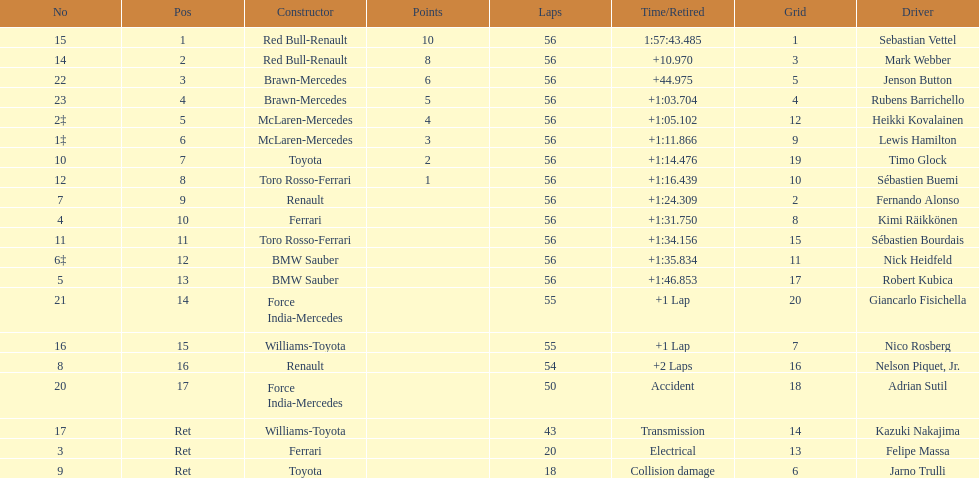What name is just previous to kazuki nakjima on the list? Adrian Sutil. Can you parse all the data within this table? {'header': ['No', 'Pos', 'Constructor', 'Points', 'Laps', 'Time/Retired', 'Grid', 'Driver'], 'rows': [['15', '1', 'Red Bull-Renault', '10', '56', '1:57:43.485', '1', 'Sebastian Vettel'], ['14', '2', 'Red Bull-Renault', '8', '56', '+10.970', '3', 'Mark Webber'], ['22', '3', 'Brawn-Mercedes', '6', '56', '+44.975', '5', 'Jenson Button'], ['23', '4', 'Brawn-Mercedes', '5', '56', '+1:03.704', '4', 'Rubens Barrichello'], ['2‡', '5', 'McLaren-Mercedes', '4', '56', '+1:05.102', '12', 'Heikki Kovalainen'], ['1‡', '6', 'McLaren-Mercedes', '3', '56', '+1:11.866', '9', 'Lewis Hamilton'], ['10', '7', 'Toyota', '2', '56', '+1:14.476', '19', 'Timo Glock'], ['12', '8', 'Toro Rosso-Ferrari', '1', '56', '+1:16.439', '10', 'Sébastien Buemi'], ['7', '9', 'Renault', '', '56', '+1:24.309', '2', 'Fernando Alonso'], ['4', '10', 'Ferrari', '', '56', '+1:31.750', '8', 'Kimi Räikkönen'], ['11', '11', 'Toro Rosso-Ferrari', '', '56', '+1:34.156', '15', 'Sébastien Bourdais'], ['6‡', '12', 'BMW Sauber', '', '56', '+1:35.834', '11', 'Nick Heidfeld'], ['5', '13', 'BMW Sauber', '', '56', '+1:46.853', '17', 'Robert Kubica'], ['21', '14', 'Force India-Mercedes', '', '55', '+1 Lap', '20', 'Giancarlo Fisichella'], ['16', '15', 'Williams-Toyota', '', '55', '+1 Lap', '7', 'Nico Rosberg'], ['8', '16', 'Renault', '', '54', '+2 Laps', '16', 'Nelson Piquet, Jr.'], ['20', '17', 'Force India-Mercedes', '', '50', 'Accident', '18', 'Adrian Sutil'], ['17', 'Ret', 'Williams-Toyota', '', '43', 'Transmission', '14', 'Kazuki Nakajima'], ['3', 'Ret', 'Ferrari', '', '20', 'Electrical', '13', 'Felipe Massa'], ['9', 'Ret', 'Toyota', '', '18', 'Collision damage', '6', 'Jarno Trulli']]} 